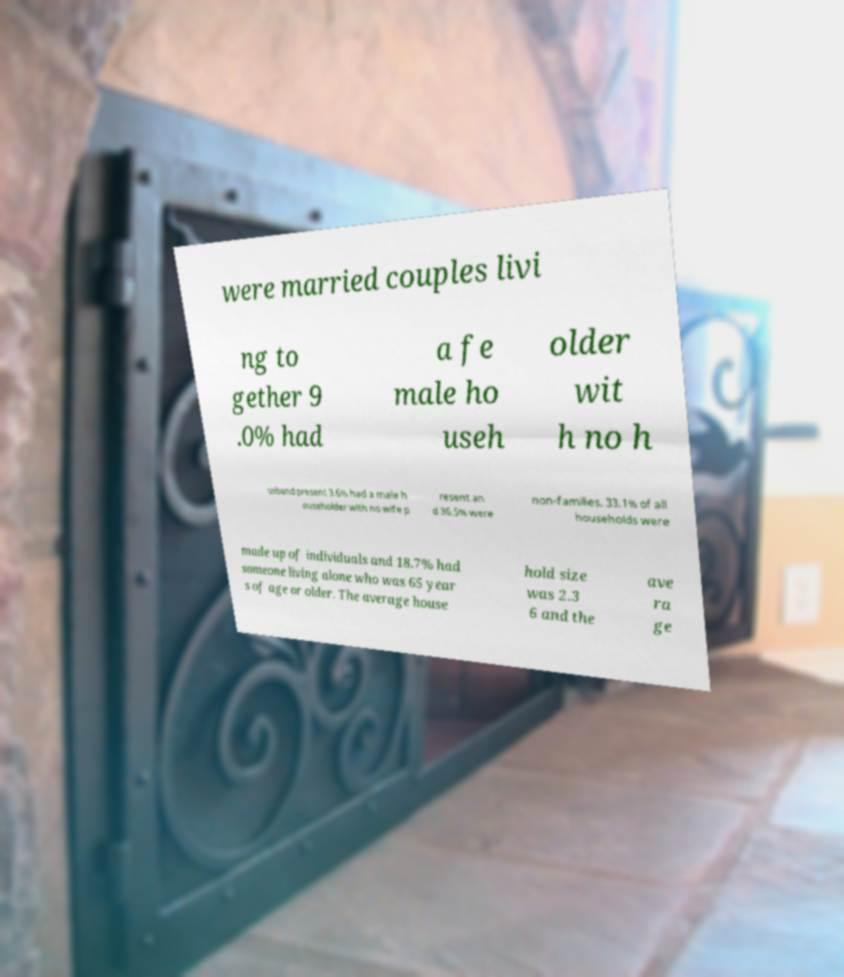I need the written content from this picture converted into text. Can you do that? were married couples livi ng to gether 9 .0% had a fe male ho useh older wit h no h usband present 3.6% had a male h ouseholder with no wife p resent an d 36.5% were non-families. 33.1% of all households were made up of individuals and 18.7% had someone living alone who was 65 year s of age or older. The average house hold size was 2.3 6 and the ave ra ge 